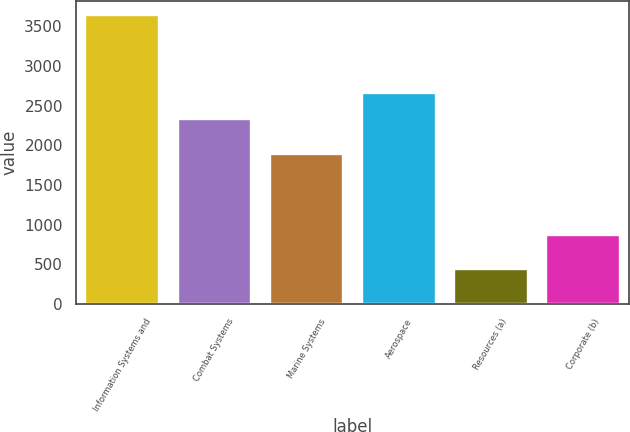Convert chart. <chart><loc_0><loc_0><loc_500><loc_500><bar_chart><fcel>Information Systems and<fcel>Combat Systems<fcel>Marine Systems<fcel>Aerospace<fcel>Resources (a)<fcel>Corporate (b)<nl><fcel>3638<fcel>2336<fcel>1887<fcel>2656<fcel>438<fcel>866<nl></chart> 